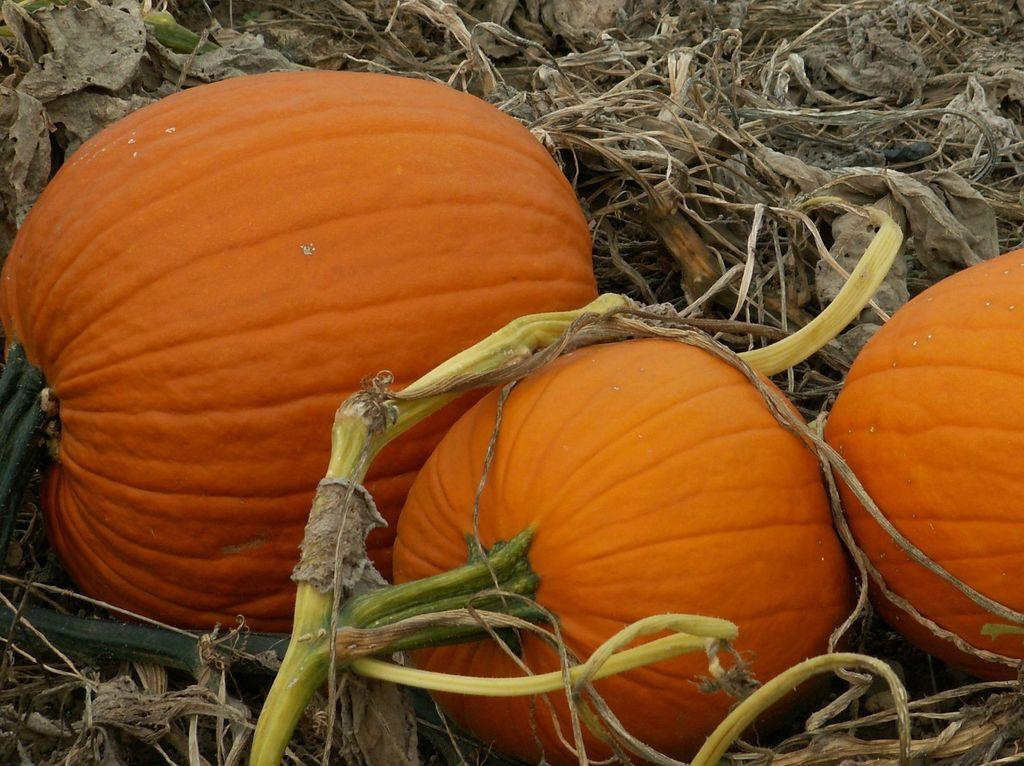What is the main subject in the center of the image? There are pumpkins in the center of the image. What can be seen at the bottom of the image? There are dried leaves at the bottom of the image. What type of machine can be seen operating in the background of the image? There is no machine present in the image; it only features pumpkins and dried leaves. 